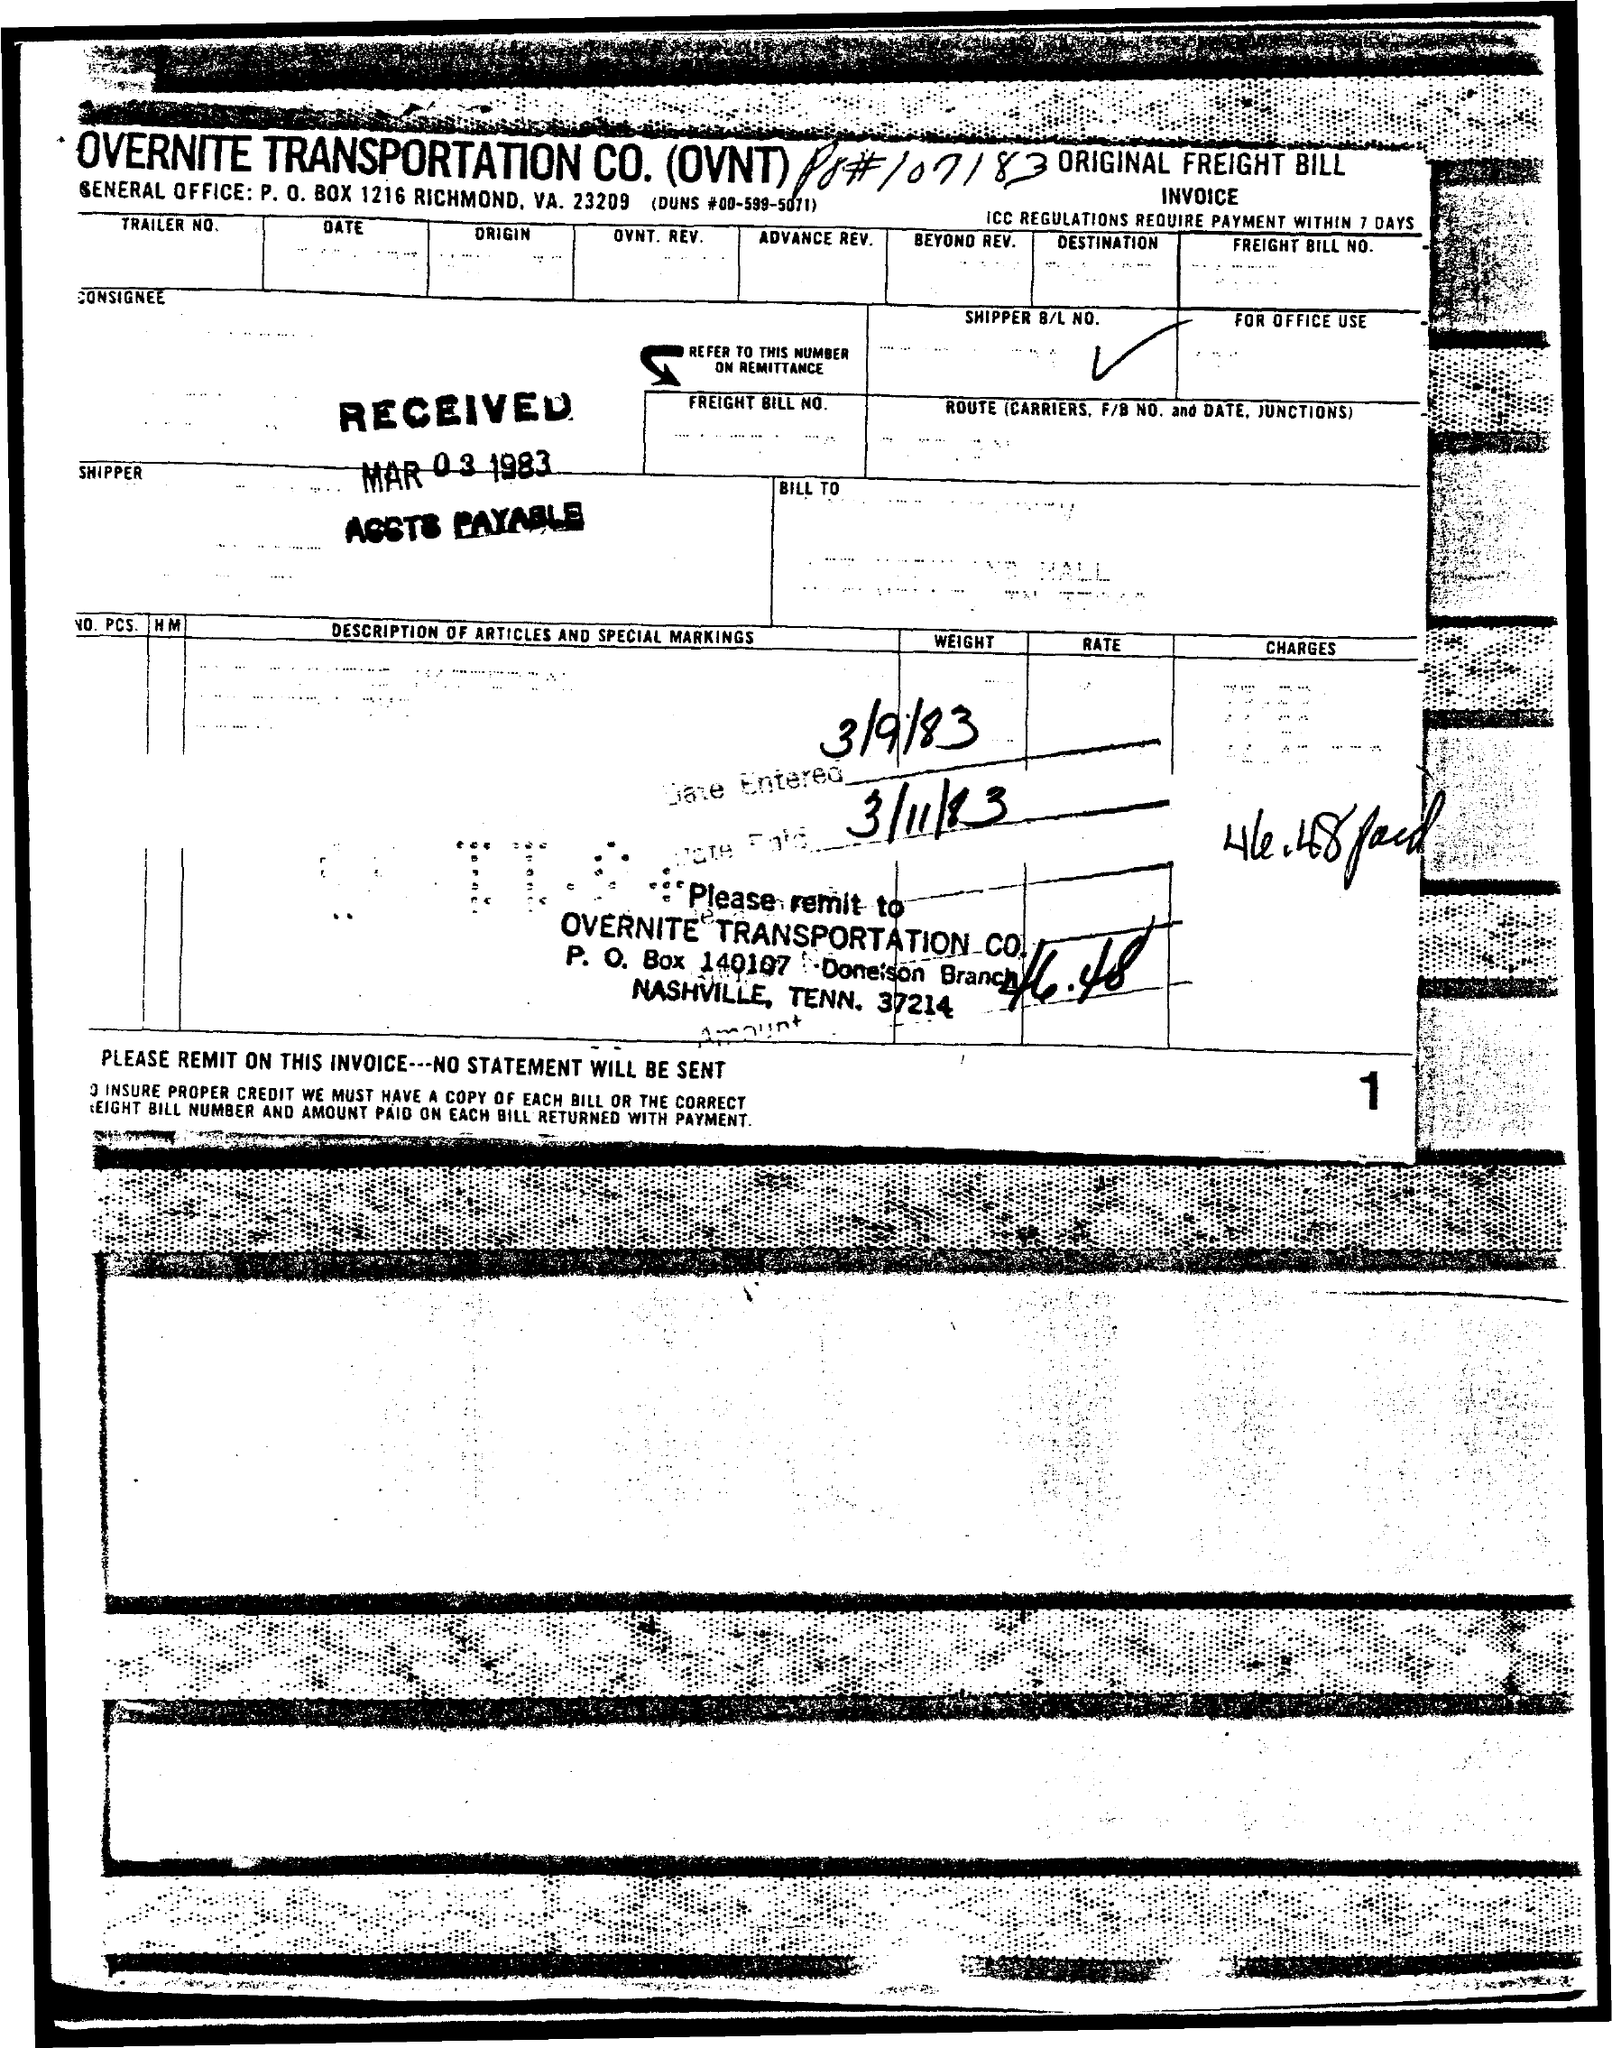What is the received date?
Keep it short and to the point. Mar 03 1983. What is the number at the bottom right of the document?
Keep it short and to the point. 1. 